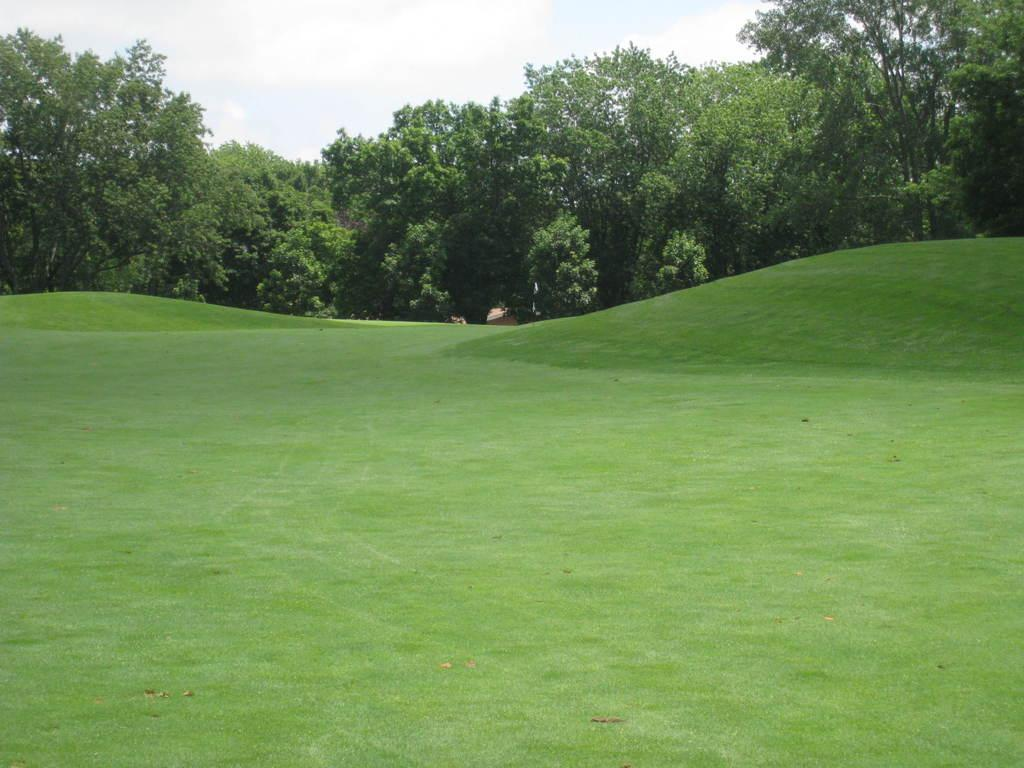What type of vegetation can be seen in the image? There is grass and trees in the image. What part of the natural environment is visible in the image? The sky is visible in the image. Can you describe the setting where the image might have been taken? The image may have been taken in a park, given the presence of grass, trees, and the sky. What type of wool is being used to knit a sweater in the image? There is no wool or sweater present in the image; it features grass, trees, and the sky. Can you tell me how the engine is functioning in the image? There is no engine present in the image; it features grass, trees, and the sky. 